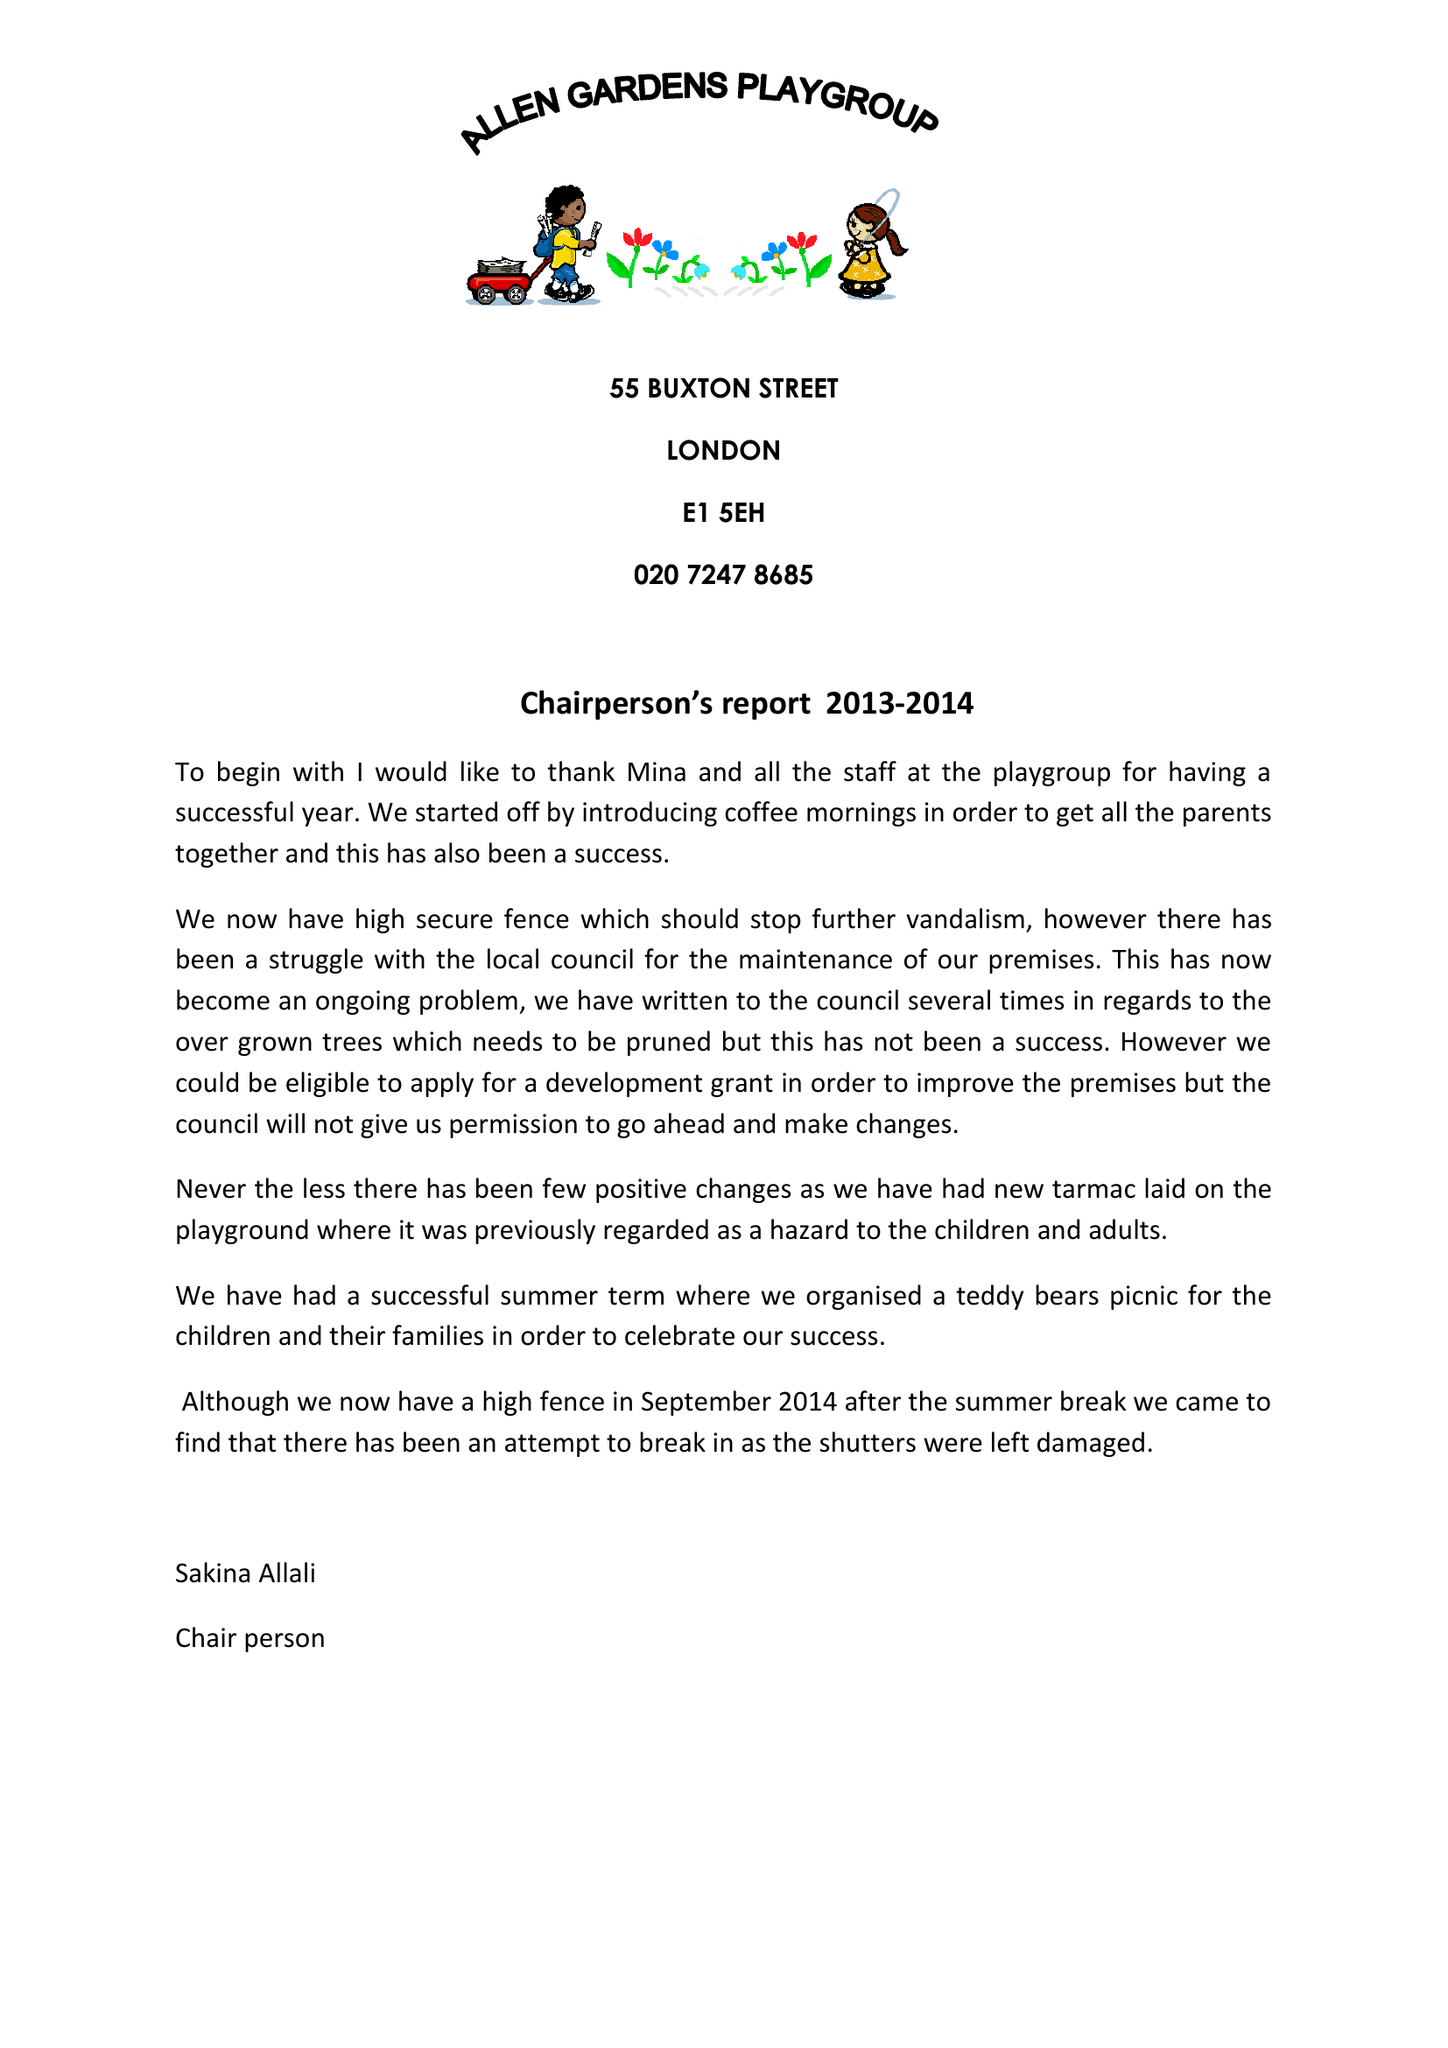What is the value for the address__post_town?
Answer the question using a single word or phrase. LONDON 